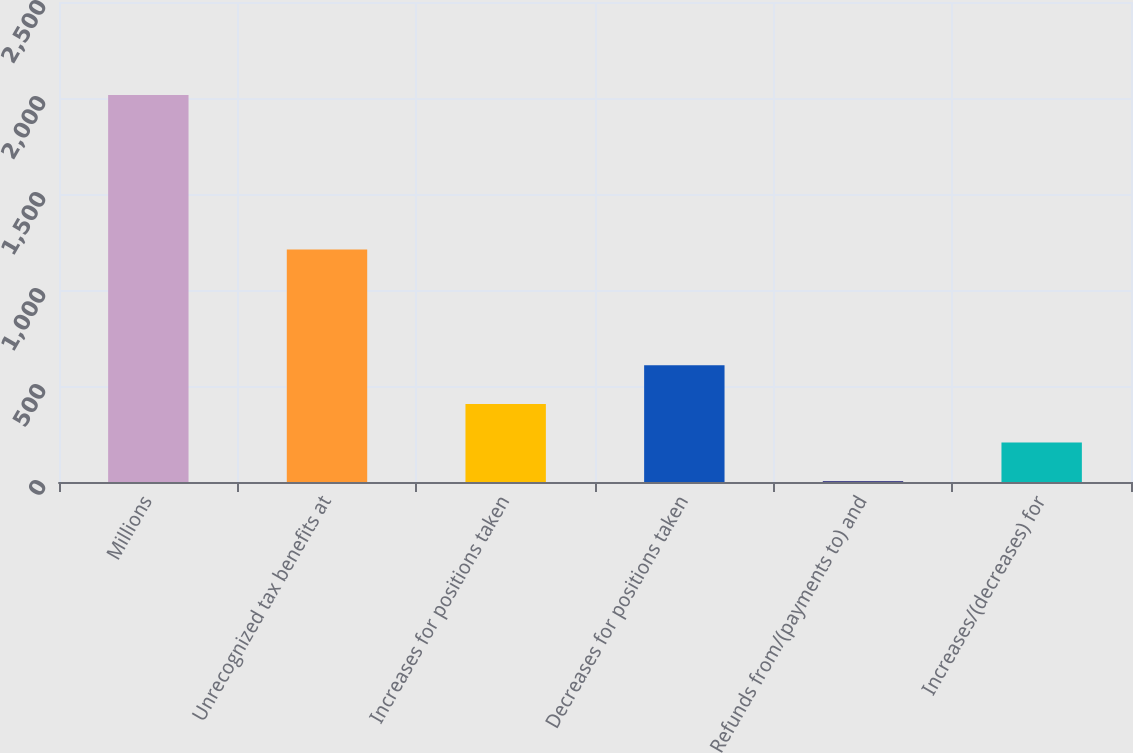Convert chart. <chart><loc_0><loc_0><loc_500><loc_500><bar_chart><fcel>Millions<fcel>Unrecognized tax benefits at<fcel>Increases for positions taken<fcel>Decreases for positions taken<fcel>Refunds from/(payments to) and<fcel>Increases/(decreases) for<nl><fcel>2016<fcel>1211.2<fcel>406.4<fcel>607.6<fcel>4<fcel>205.2<nl></chart> 